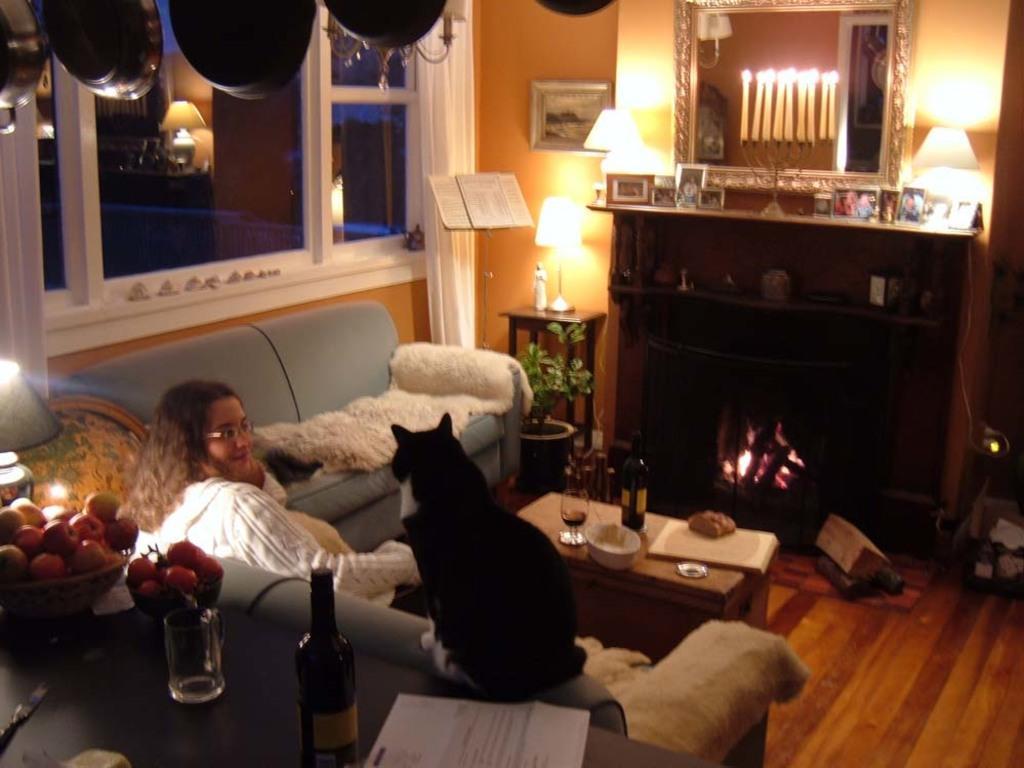Could you give a brief overview of what you see in this image? In this image i can see a lady person sitting on the couch and a cat at the foreground of the image there some fruits,glass and bottle on top of the table and at the background of the image there are lamps,books,camp fire and candles. 